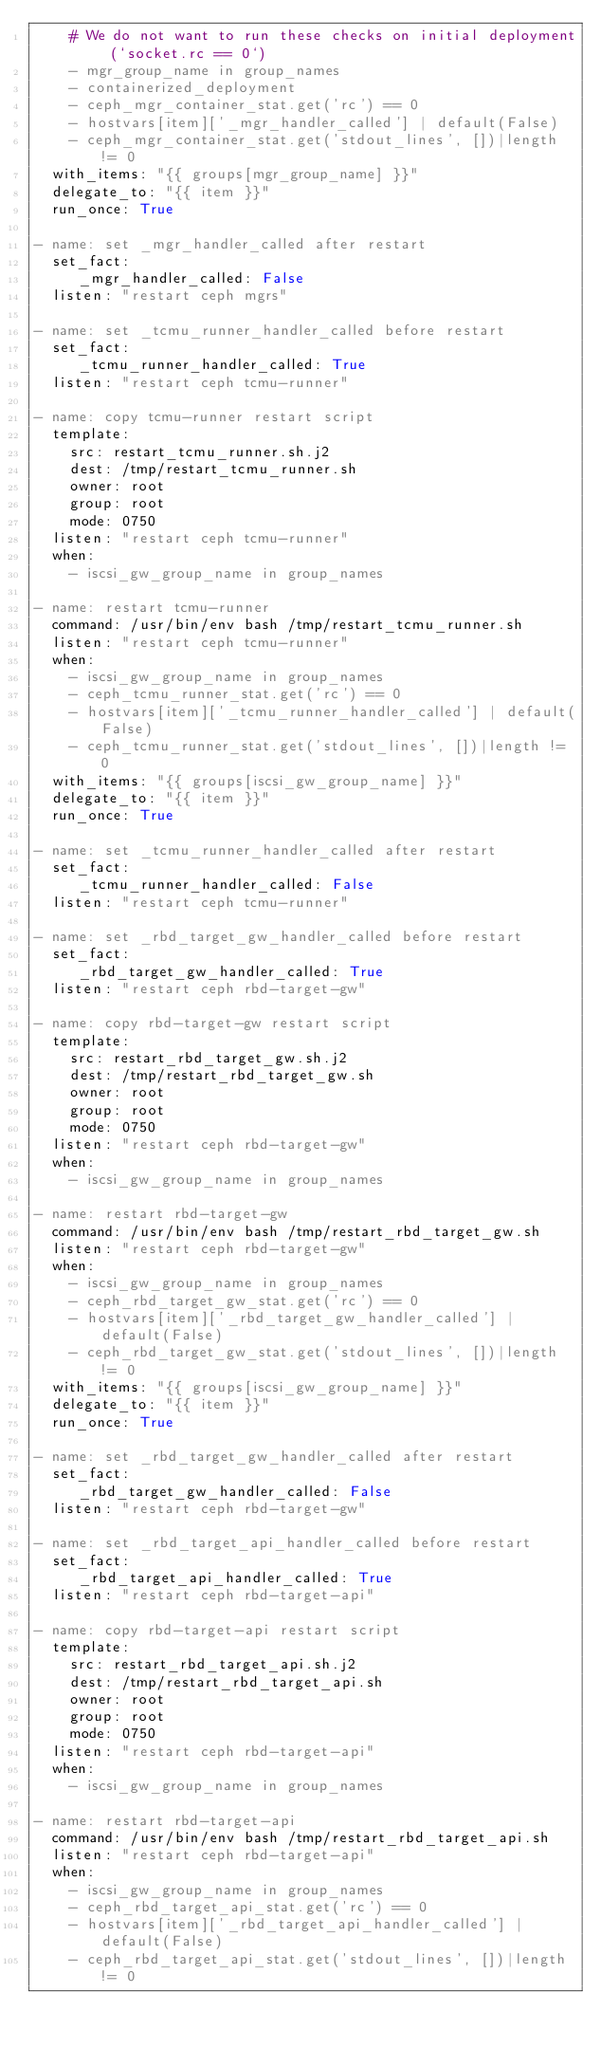Convert code to text. <code><loc_0><loc_0><loc_500><loc_500><_YAML_>    # We do not want to run these checks on initial deployment (`socket.rc == 0`)
    - mgr_group_name in group_names
    - containerized_deployment
    - ceph_mgr_container_stat.get('rc') == 0
    - hostvars[item]['_mgr_handler_called'] | default(False)
    - ceph_mgr_container_stat.get('stdout_lines', [])|length != 0
  with_items: "{{ groups[mgr_group_name] }}"
  delegate_to: "{{ item }}"
  run_once: True

- name: set _mgr_handler_called after restart
  set_fact:
     _mgr_handler_called: False
  listen: "restart ceph mgrs"

- name: set _tcmu_runner_handler_called before restart
  set_fact:
     _tcmu_runner_handler_called: True
  listen: "restart ceph tcmu-runner"

- name: copy tcmu-runner restart script
  template:
    src: restart_tcmu_runner.sh.j2
    dest: /tmp/restart_tcmu_runner.sh
    owner: root
    group: root
    mode: 0750
  listen: "restart ceph tcmu-runner"
  when:
    - iscsi_gw_group_name in group_names

- name: restart tcmu-runner
  command: /usr/bin/env bash /tmp/restart_tcmu_runner.sh
  listen: "restart ceph tcmu-runner"
  when:
    - iscsi_gw_group_name in group_names
    - ceph_tcmu_runner_stat.get('rc') == 0
    - hostvars[item]['_tcmu_runner_handler_called'] | default(False)
    - ceph_tcmu_runner_stat.get('stdout_lines', [])|length != 0
  with_items: "{{ groups[iscsi_gw_group_name] }}"
  delegate_to: "{{ item }}"
  run_once: True

- name: set _tcmu_runner_handler_called after restart
  set_fact:
     _tcmu_runner_handler_called: False
  listen: "restart ceph tcmu-runner"

- name: set _rbd_target_gw_handler_called before restart
  set_fact:
     _rbd_target_gw_handler_called: True
  listen: "restart ceph rbd-target-gw"

- name: copy rbd-target-gw restart script
  template:
    src: restart_rbd_target_gw.sh.j2
    dest: /tmp/restart_rbd_target_gw.sh
    owner: root
    group: root
    mode: 0750
  listen: "restart ceph rbd-target-gw"
  when:
    - iscsi_gw_group_name in group_names

- name: restart rbd-target-gw
  command: /usr/bin/env bash /tmp/restart_rbd_target_gw.sh
  listen: "restart ceph rbd-target-gw"
  when:
    - iscsi_gw_group_name in group_names
    - ceph_rbd_target_gw_stat.get('rc') == 0
    - hostvars[item]['_rbd_target_gw_handler_called'] | default(False)
    - ceph_rbd_target_gw_stat.get('stdout_lines', [])|length != 0
  with_items: "{{ groups[iscsi_gw_group_name] }}"
  delegate_to: "{{ item }}"
  run_once: True

- name: set _rbd_target_gw_handler_called after restart
  set_fact:
     _rbd_target_gw_handler_called: False
  listen: "restart ceph rbd-target-gw"

- name: set _rbd_target_api_handler_called before restart
  set_fact:
     _rbd_target_api_handler_called: True
  listen: "restart ceph rbd-target-api"

- name: copy rbd-target-api restart script
  template:
    src: restart_rbd_target_api.sh.j2
    dest: /tmp/restart_rbd_target_api.sh
    owner: root
    group: root
    mode: 0750
  listen: "restart ceph rbd-target-api"
  when:
    - iscsi_gw_group_name in group_names

- name: restart rbd-target-api
  command: /usr/bin/env bash /tmp/restart_rbd_target_api.sh
  listen: "restart ceph rbd-target-api"
  when:
    - iscsi_gw_group_name in group_names
    - ceph_rbd_target_api_stat.get('rc') == 0
    - hostvars[item]['_rbd_target_api_handler_called'] | default(False)
    - ceph_rbd_target_api_stat.get('stdout_lines', [])|length != 0</code> 